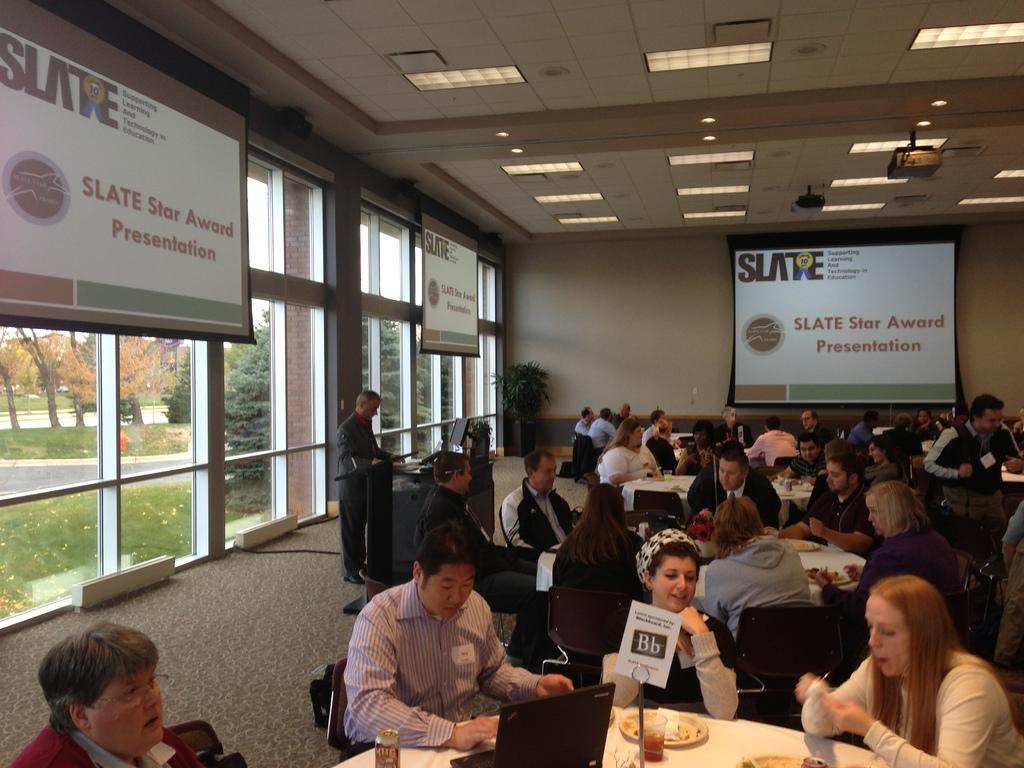In one or two sentences, can you explain what this image depicts? In this image I can see number of persons are sitting on chairs around the table. On the tables I can see few plates, few glasses, a laptop which is black in color and few other objects. I can see a person standing in front of a desk and a monitor on the desk. I can see few screens, the ceiling, few lights to the ceiling, the wall, a plant and few glass windows through which I can see few trees, the road and the sky. 